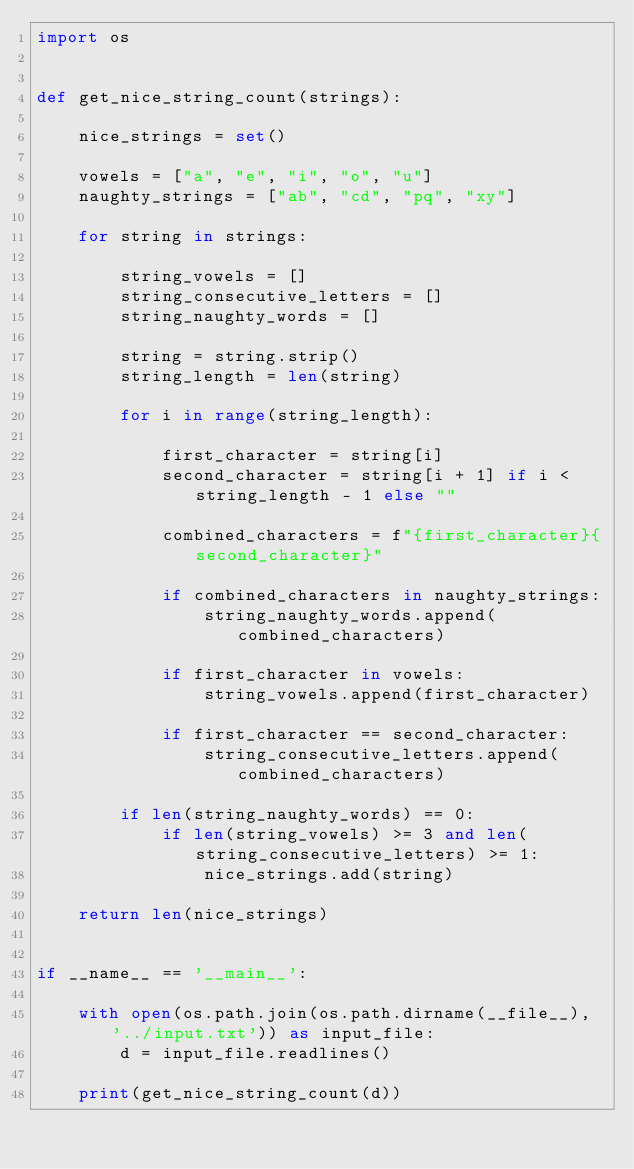Convert code to text. <code><loc_0><loc_0><loc_500><loc_500><_Python_>import os


def get_nice_string_count(strings):

    nice_strings = set()

    vowels = ["a", "e", "i", "o", "u"]
    naughty_strings = ["ab", "cd", "pq", "xy"]

    for string in strings:

        string_vowels = []
        string_consecutive_letters = []
        string_naughty_words = []

        string = string.strip()
        string_length = len(string)

        for i in range(string_length):

            first_character = string[i]
            second_character = string[i + 1] if i < string_length - 1 else ""

            combined_characters = f"{first_character}{second_character}"

            if combined_characters in naughty_strings:
                string_naughty_words.append(combined_characters)

            if first_character in vowels:
                string_vowels.append(first_character)

            if first_character == second_character:
                string_consecutive_letters.append(combined_characters)

        if len(string_naughty_words) == 0:
            if len(string_vowels) >= 3 and len(string_consecutive_letters) >= 1:
                nice_strings.add(string)

    return len(nice_strings)


if __name__ == '__main__':

    with open(os.path.join(os.path.dirname(__file__), '../input.txt')) as input_file:
        d = input_file.readlines()

    print(get_nice_string_count(d))
</code> 